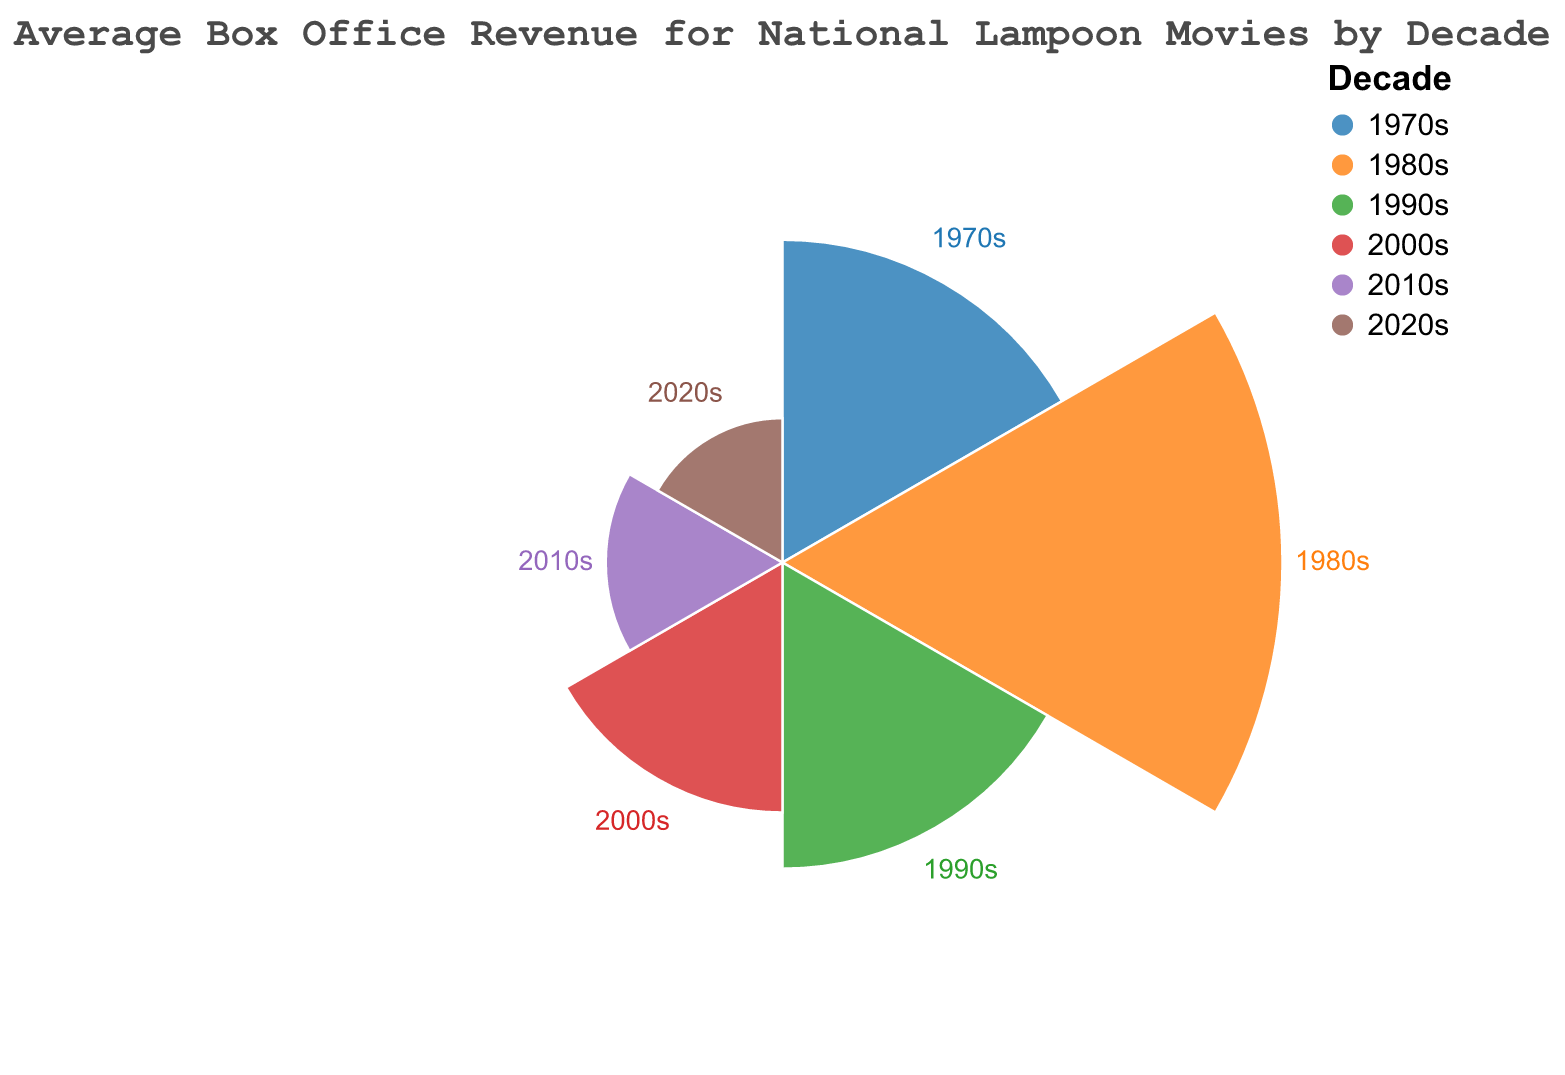what is the title of the figure? The title of the figure is prominently displayed at the top of the chart. It reads "Average Box Office Revenue for National Lampoon Movies by Decade".
Answer: Average Box Office Revenue for National Lampoon Movies by Decade which decade had the highest average box office revenue? By observing the lengths of the arcs, we can see that the 1980s segment extends furthest from the center of the chart, indicating it has the highest value.
Answer: 1980s how many decades are represented in the figure? Each segment corresponds to a different decade, and by counting these segments, we find there are six in total.
Answer: 6 which decades have a box office revenue less than 50? We compare the radial lengths of the segments and find that the 2000s, 2010s, and 2020s segments are less extended than the 50-unit mark.
Answer: 2000s, 2010s, 2020s how does the average box office revenue in the 1990s compare to the 1970s? The 1990s segment is shorter than the 1970s segment, indicating that the average box office revenue is lower in the 1990s compared to the 1970s.
Answer: The 1990s are lower than the 1970s by how much did the average box office revenue decrease from the 1980s to the 2020s? The average box office revenue in the 1980s is 120, and in the 2020s, it is 10. The difference is calculated as 120 - 10.
Answer: 110 what is the total average box office revenue across all decades? Summing up the average box office revenues for each decade, we get 50 (1970s) + 120 (1980s) + 45 (1990s) + 30 (2000s) + 15 (2010s) + 10 (2020s).
Answer: 270 which decade had the second lowest average box office revenue? Among the shorter segments, the 2020s segment is the shortest, making it the lowest. The next shortest is the 2010s segment.
Answer: 2010s what is the difference in average box office revenue between the 2000s and 2010s? The average box office revenue in the 2000s is 30, and in the 2010s, it is 15. The difference is calculated as 30 - 15.
Answer: 15 what patterns can be observed in the average box office revenue over the decades? Observing the visual trend, it is noticeable that the average box office revenue rises from the 1970s to reach its peak in the 1980s, and then steadily declines through the subsequent decades up to the 2020s.
Answer: Rises in the 1980s, then declines 